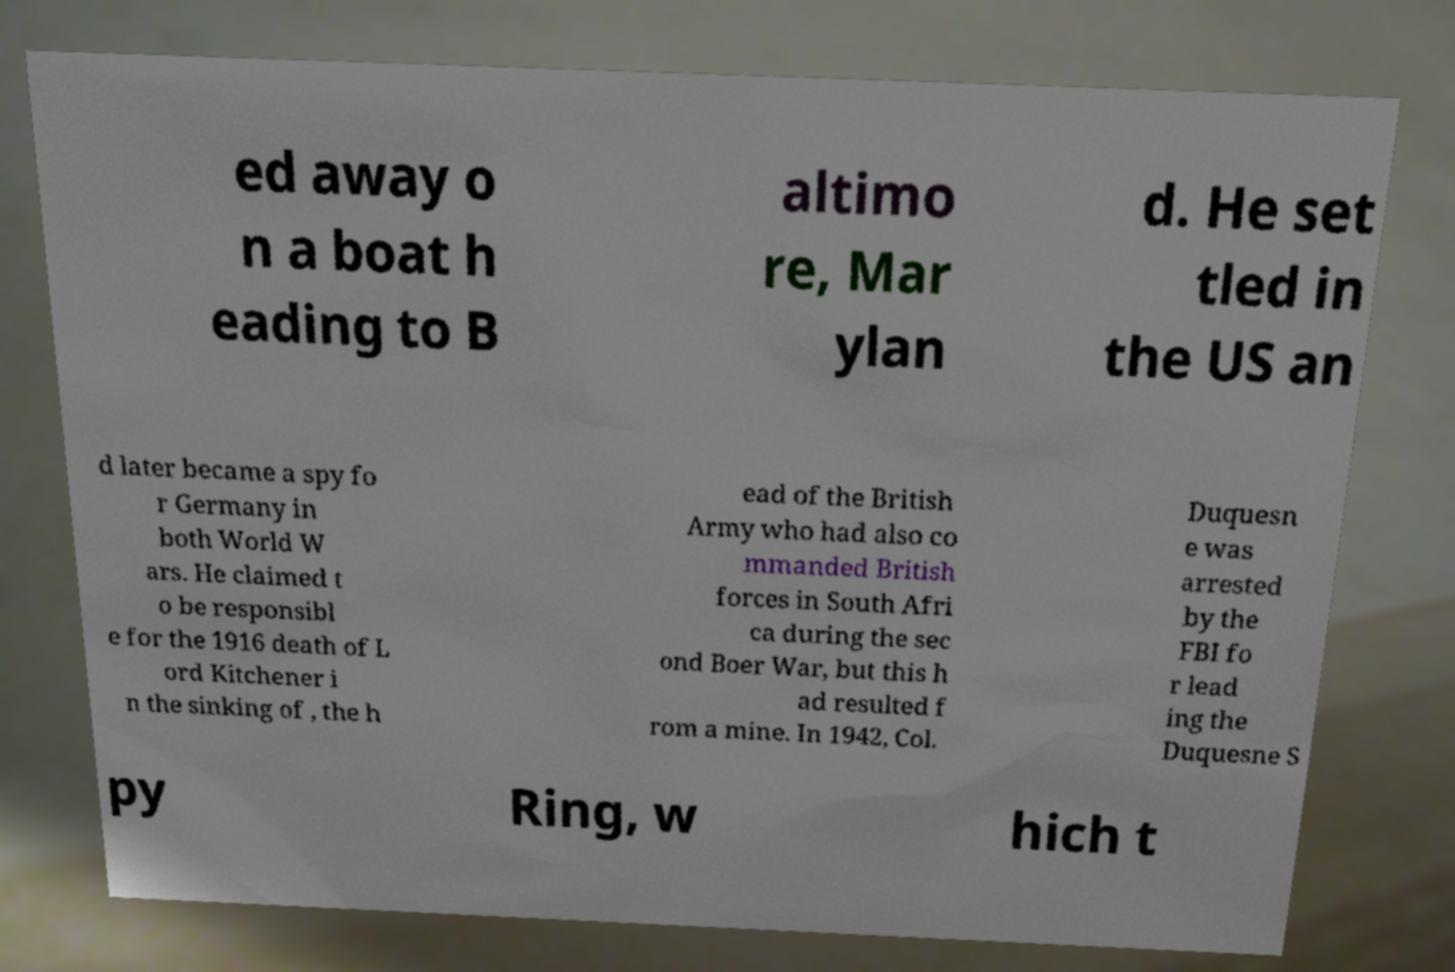Can you accurately transcribe the text from the provided image for me? ed away o n a boat h eading to B altimo re, Mar ylan d. He set tled in the US an d later became a spy fo r Germany in both World W ars. He claimed t o be responsibl e for the 1916 death of L ord Kitchener i n the sinking of , the h ead of the British Army who had also co mmanded British forces in South Afri ca during the sec ond Boer War, but this h ad resulted f rom a mine. In 1942, Col. Duquesn e was arrested by the FBI fo r lead ing the Duquesne S py Ring, w hich t 